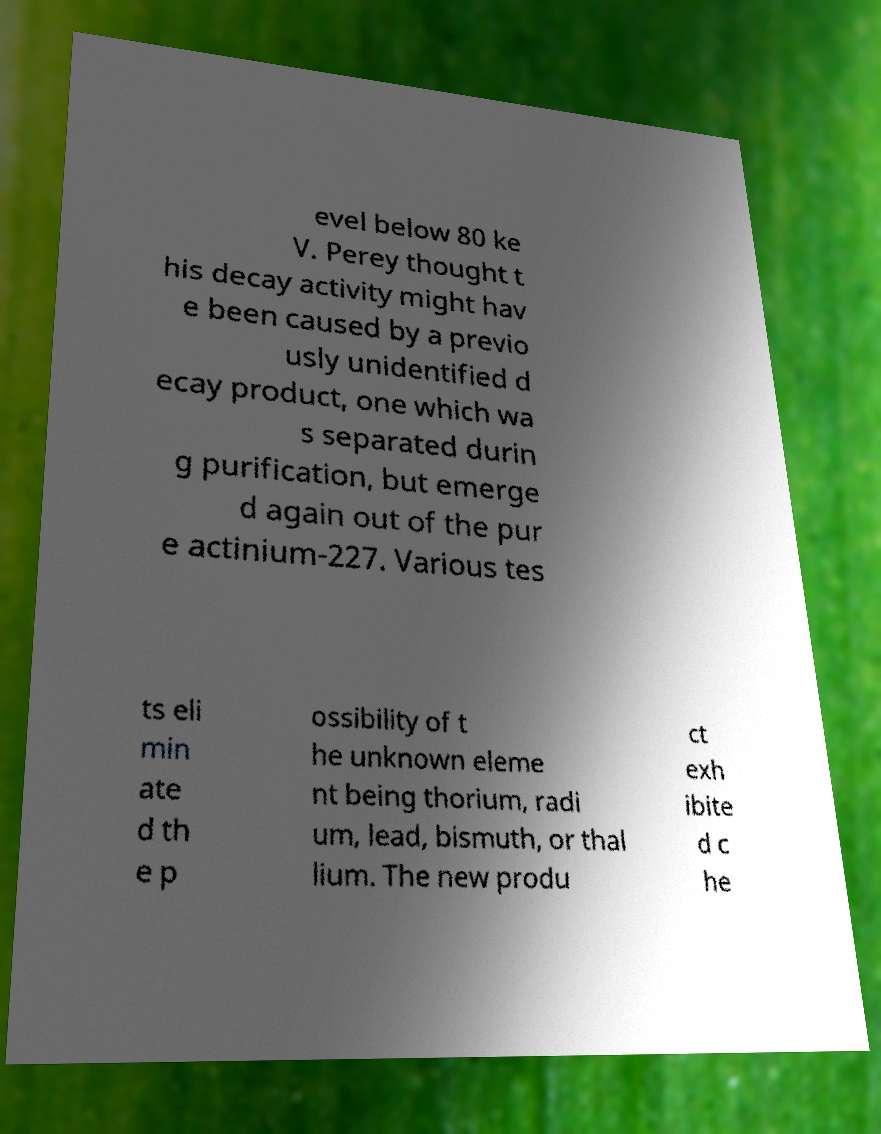There's text embedded in this image that I need extracted. Can you transcribe it verbatim? evel below 80 ke V. Perey thought t his decay activity might hav e been caused by a previo usly unidentified d ecay product, one which wa s separated durin g purification, but emerge d again out of the pur e actinium-227. Various tes ts eli min ate d th e p ossibility of t he unknown eleme nt being thorium, radi um, lead, bismuth, or thal lium. The new produ ct exh ibite d c he 